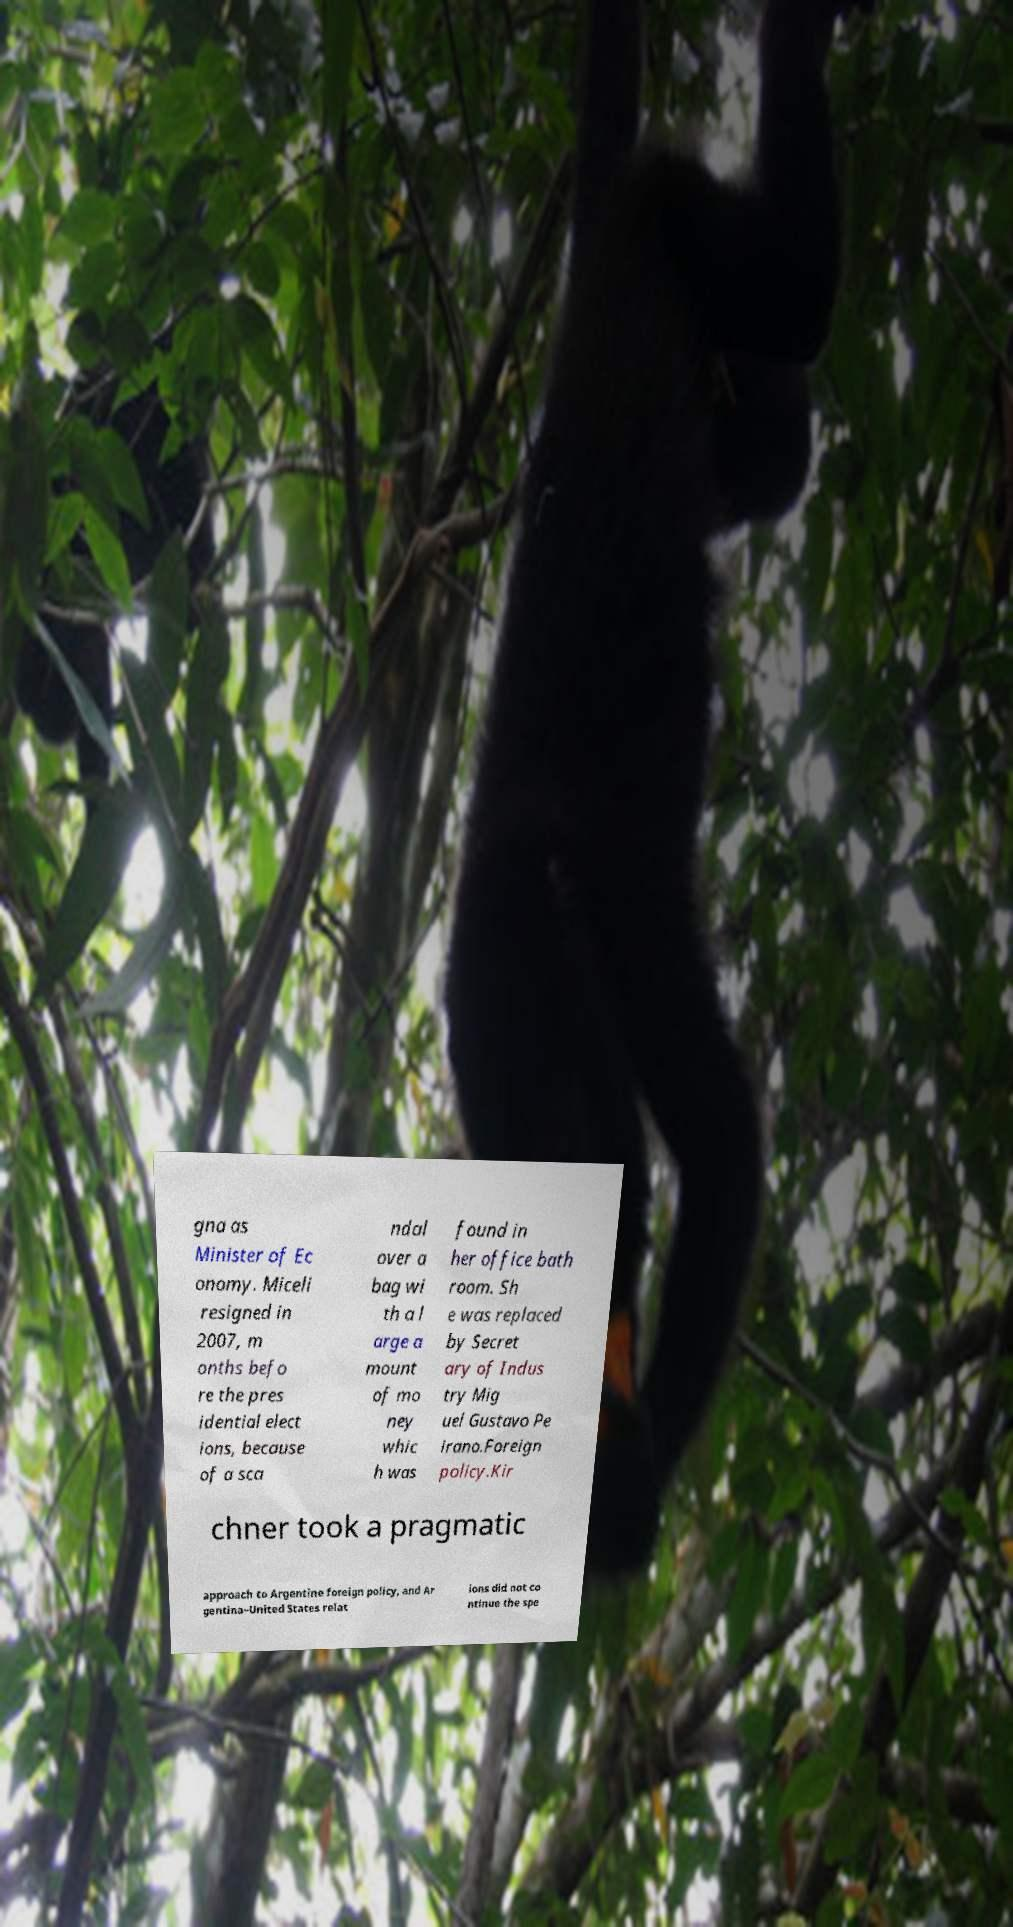Please identify and transcribe the text found in this image. gna as Minister of Ec onomy. Miceli resigned in 2007, m onths befo re the pres idential elect ions, because of a sca ndal over a bag wi th a l arge a mount of mo ney whic h was found in her office bath room. Sh e was replaced by Secret ary of Indus try Mig uel Gustavo Pe irano.Foreign policy.Kir chner took a pragmatic approach to Argentine foreign policy, and Ar gentina–United States relat ions did not co ntinue the spe 